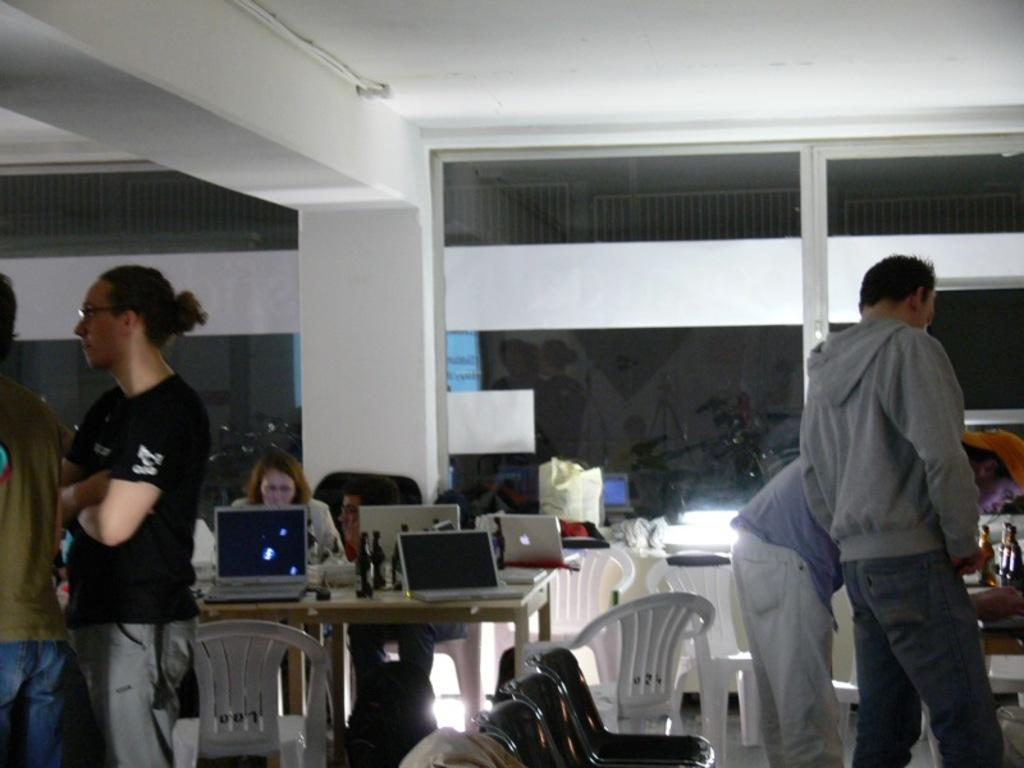How many people are present in the image? There are four people standing in the image. What is the woman in the image doing? A woman is sitting on a chair in the image. What electronic device can be seen on a table in the image? There is a laptop on a table in the image. What type of architectural feature is visible in the background of the image? There is a pillar in the background of the image. What type of coat is the woman wearing in the image? The woman is sitting on a chair, but there is no mention of a coat in the image. Is there any milk visible in the image? There is no mention of milk in the image. 